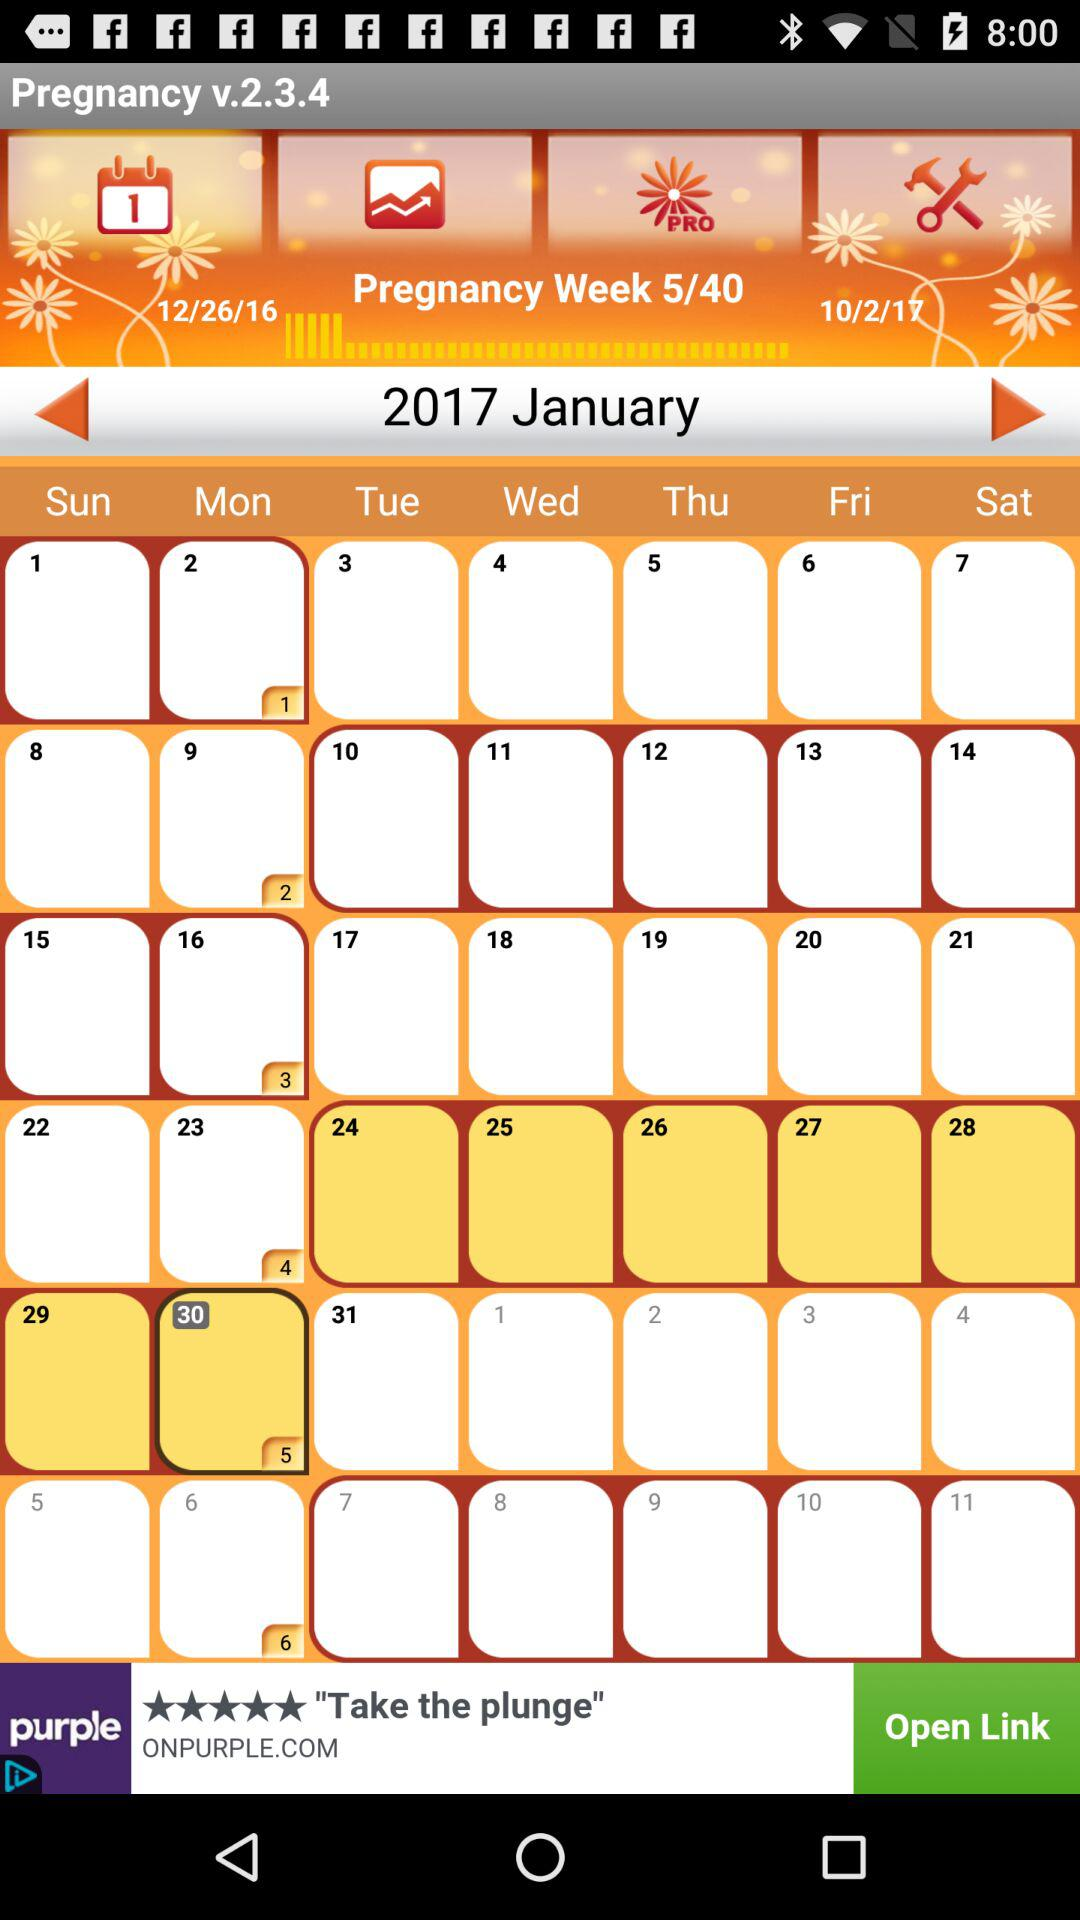What are the month and year given on the calendar? The given month is January and the year is 2017. 